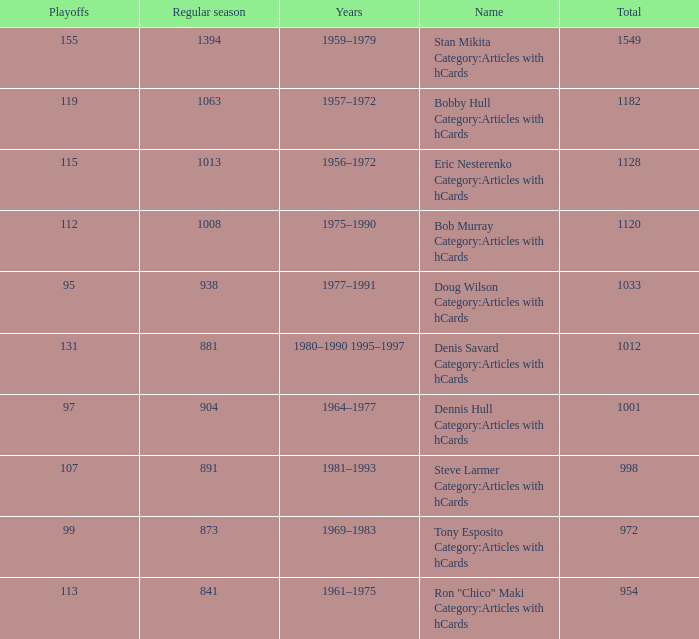How may times is regular season 1063 and playoffs more than 119? 0.0. 